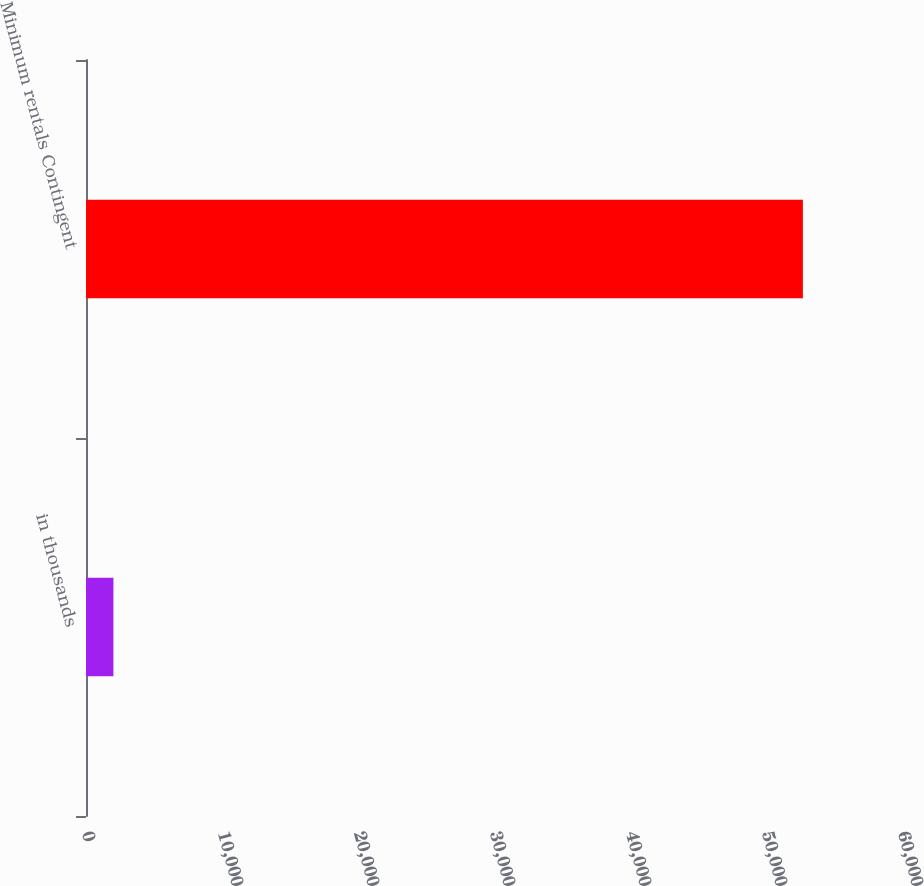<chart> <loc_0><loc_0><loc_500><loc_500><bar_chart><fcel>in thousands<fcel>Minimum rentals Contingent<nl><fcel>2016<fcel>52713<nl></chart> 